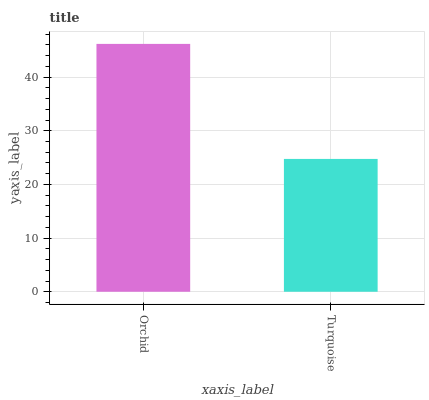Is Turquoise the minimum?
Answer yes or no. Yes. Is Orchid the maximum?
Answer yes or no. Yes. Is Turquoise the maximum?
Answer yes or no. No. Is Orchid greater than Turquoise?
Answer yes or no. Yes. Is Turquoise less than Orchid?
Answer yes or no. Yes. Is Turquoise greater than Orchid?
Answer yes or no. No. Is Orchid less than Turquoise?
Answer yes or no. No. Is Orchid the high median?
Answer yes or no. Yes. Is Turquoise the low median?
Answer yes or no. Yes. Is Turquoise the high median?
Answer yes or no. No. Is Orchid the low median?
Answer yes or no. No. 